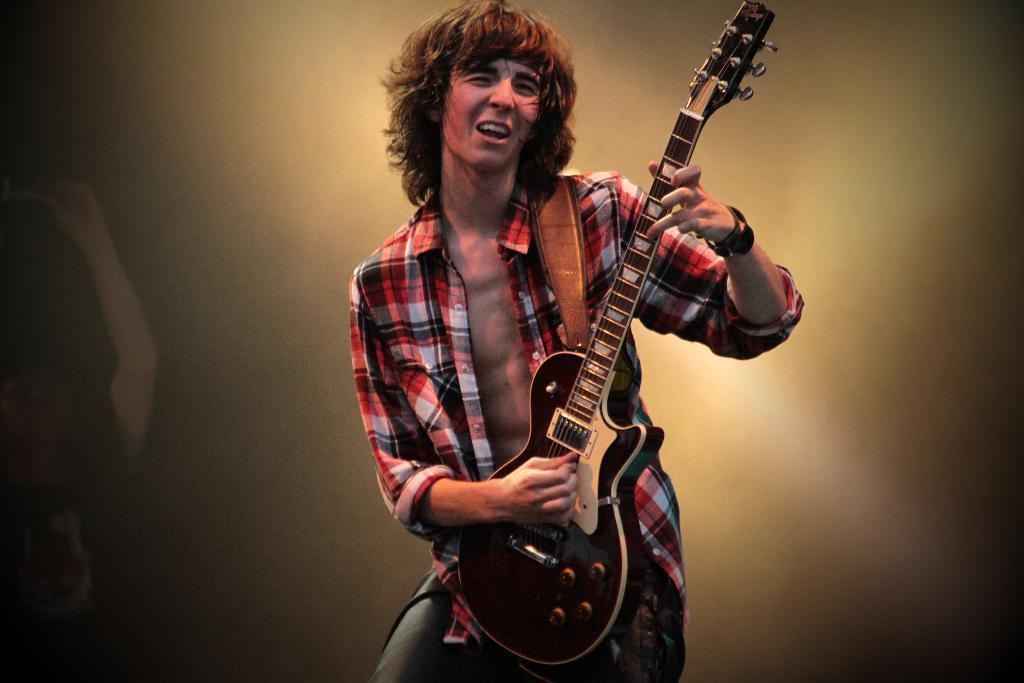How would you summarize this image in a sentence or two? In this image there is a man standing. He is playing a guitar. He is singing. To the left there is an object. The background is blurry. 